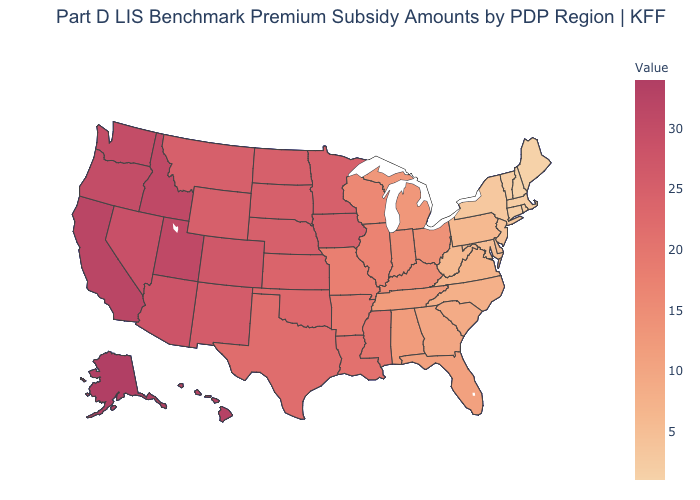Does the map have missing data?
Keep it brief. No. Which states have the highest value in the USA?
Concise answer only. Alaska. Does the map have missing data?
Concise answer only. No. Among the states that border Tennessee , does Alabama have the highest value?
Short answer required. No. Is the legend a continuous bar?
Short answer required. Yes. Among the states that border Arkansas , which have the highest value?
Short answer required. Oklahoma. Which states have the lowest value in the USA?
Concise answer only. Maine, New Hampshire. 